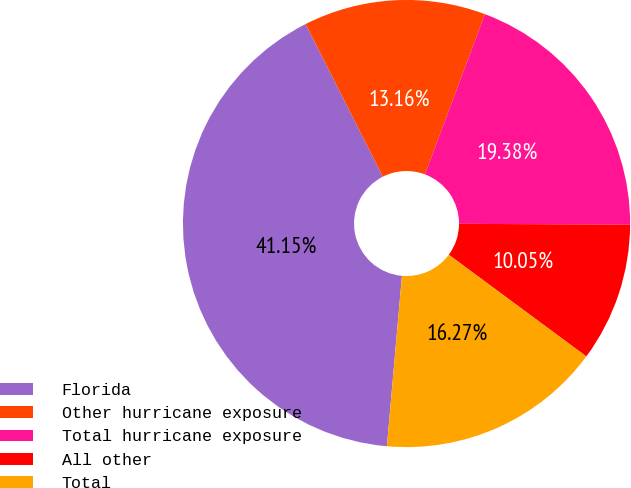Convert chart to OTSL. <chart><loc_0><loc_0><loc_500><loc_500><pie_chart><fcel>Florida<fcel>Other hurricane exposure<fcel>Total hurricane exposure<fcel>All other<fcel>Total<nl><fcel>41.15%<fcel>13.16%<fcel>19.38%<fcel>10.05%<fcel>16.27%<nl></chart> 